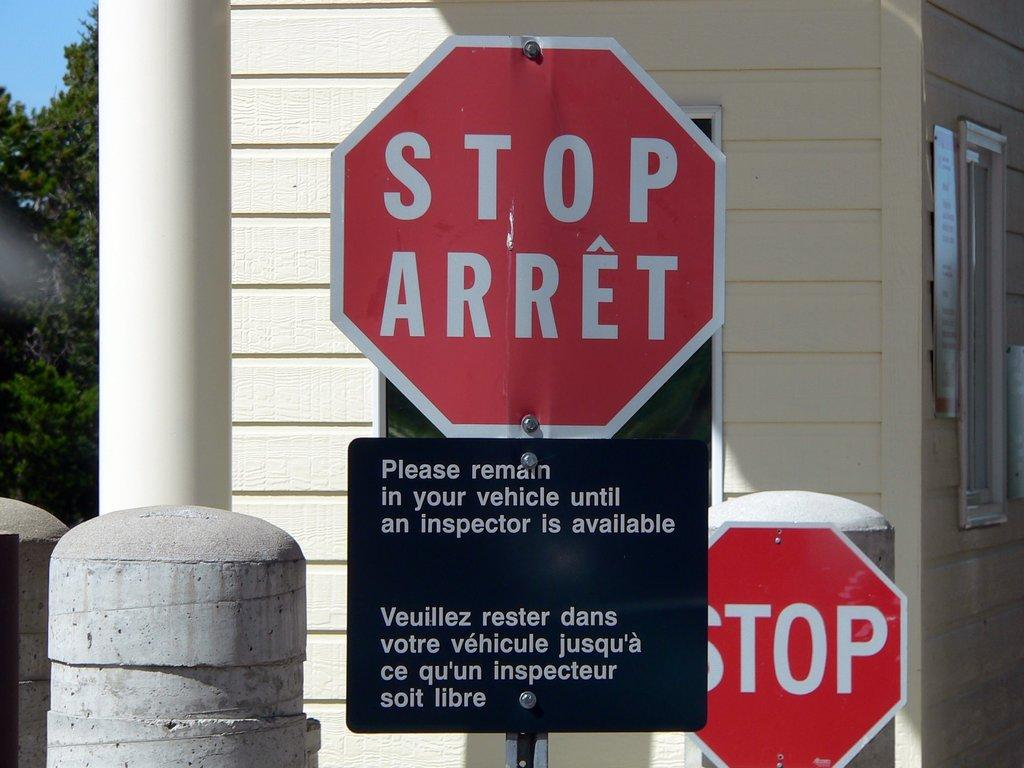<image>
Summarize the visual content of the image. Vehicles are required to stop and be inspected before entry. 